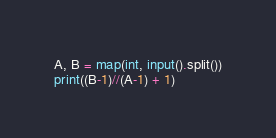<code> <loc_0><loc_0><loc_500><loc_500><_Python_>A, B = map(int, input().split())
print((B-1)//(A-1) + 1)</code> 